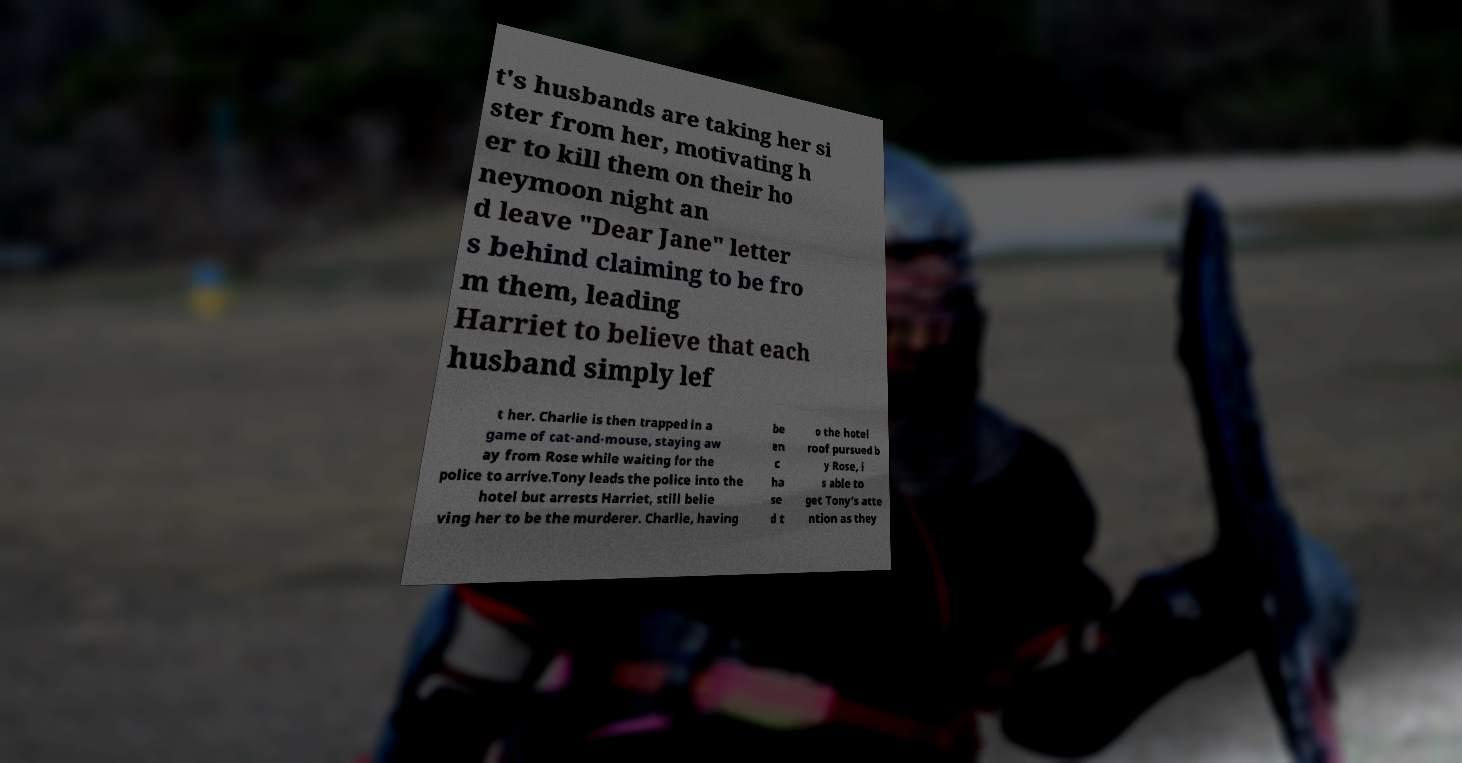Can you read and provide the text displayed in the image?This photo seems to have some interesting text. Can you extract and type it out for me? t's husbands are taking her si ster from her, motivating h er to kill them on their ho neymoon night an d leave "Dear Jane" letter s behind claiming to be fro m them, leading Harriet to believe that each husband simply lef t her. Charlie is then trapped in a game of cat-and-mouse, staying aw ay from Rose while waiting for the police to arrive.Tony leads the police into the hotel but arrests Harriet, still belie ving her to be the murderer. Charlie, having be en c ha se d t o the hotel roof pursued b y Rose, i s able to get Tony’s atte ntion as they 